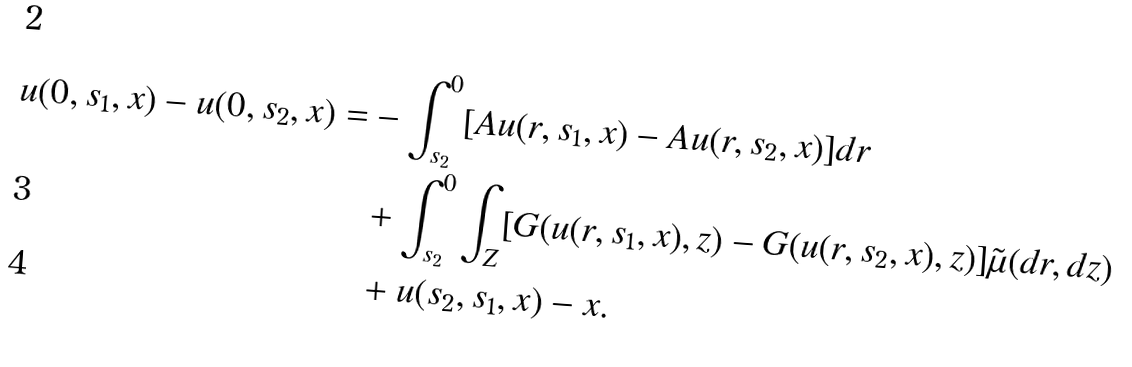<formula> <loc_0><loc_0><loc_500><loc_500>u ( 0 , s _ { 1 } , x ) - u ( 0 , s _ { 2 } , x ) = & - \int _ { s _ { 2 } } ^ { 0 } [ A u ( r , s _ { 1 } , x ) - A u ( r , s _ { 2 } , x ) ] d r \\ & + \int _ { s _ { 2 } } ^ { 0 } \int _ { Z } [ G ( u ( r , s _ { 1 } , x ) , z ) - G ( u ( r , s _ { 2 } , x ) , z ) ] \tilde { \mu } ( d r , d z ) \\ & + u ( s _ { 2 } , s _ { 1 } , x ) - x .</formula> 